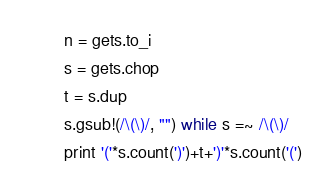Convert code to text. <code><loc_0><loc_0><loc_500><loc_500><_Ruby_>n = gets.to_i
s = gets.chop
t = s.dup
s.gsub!(/\(\)/, "") while s =~ /\(\)/
print '('*s.count(')')+t+')'*s.count('(')</code> 